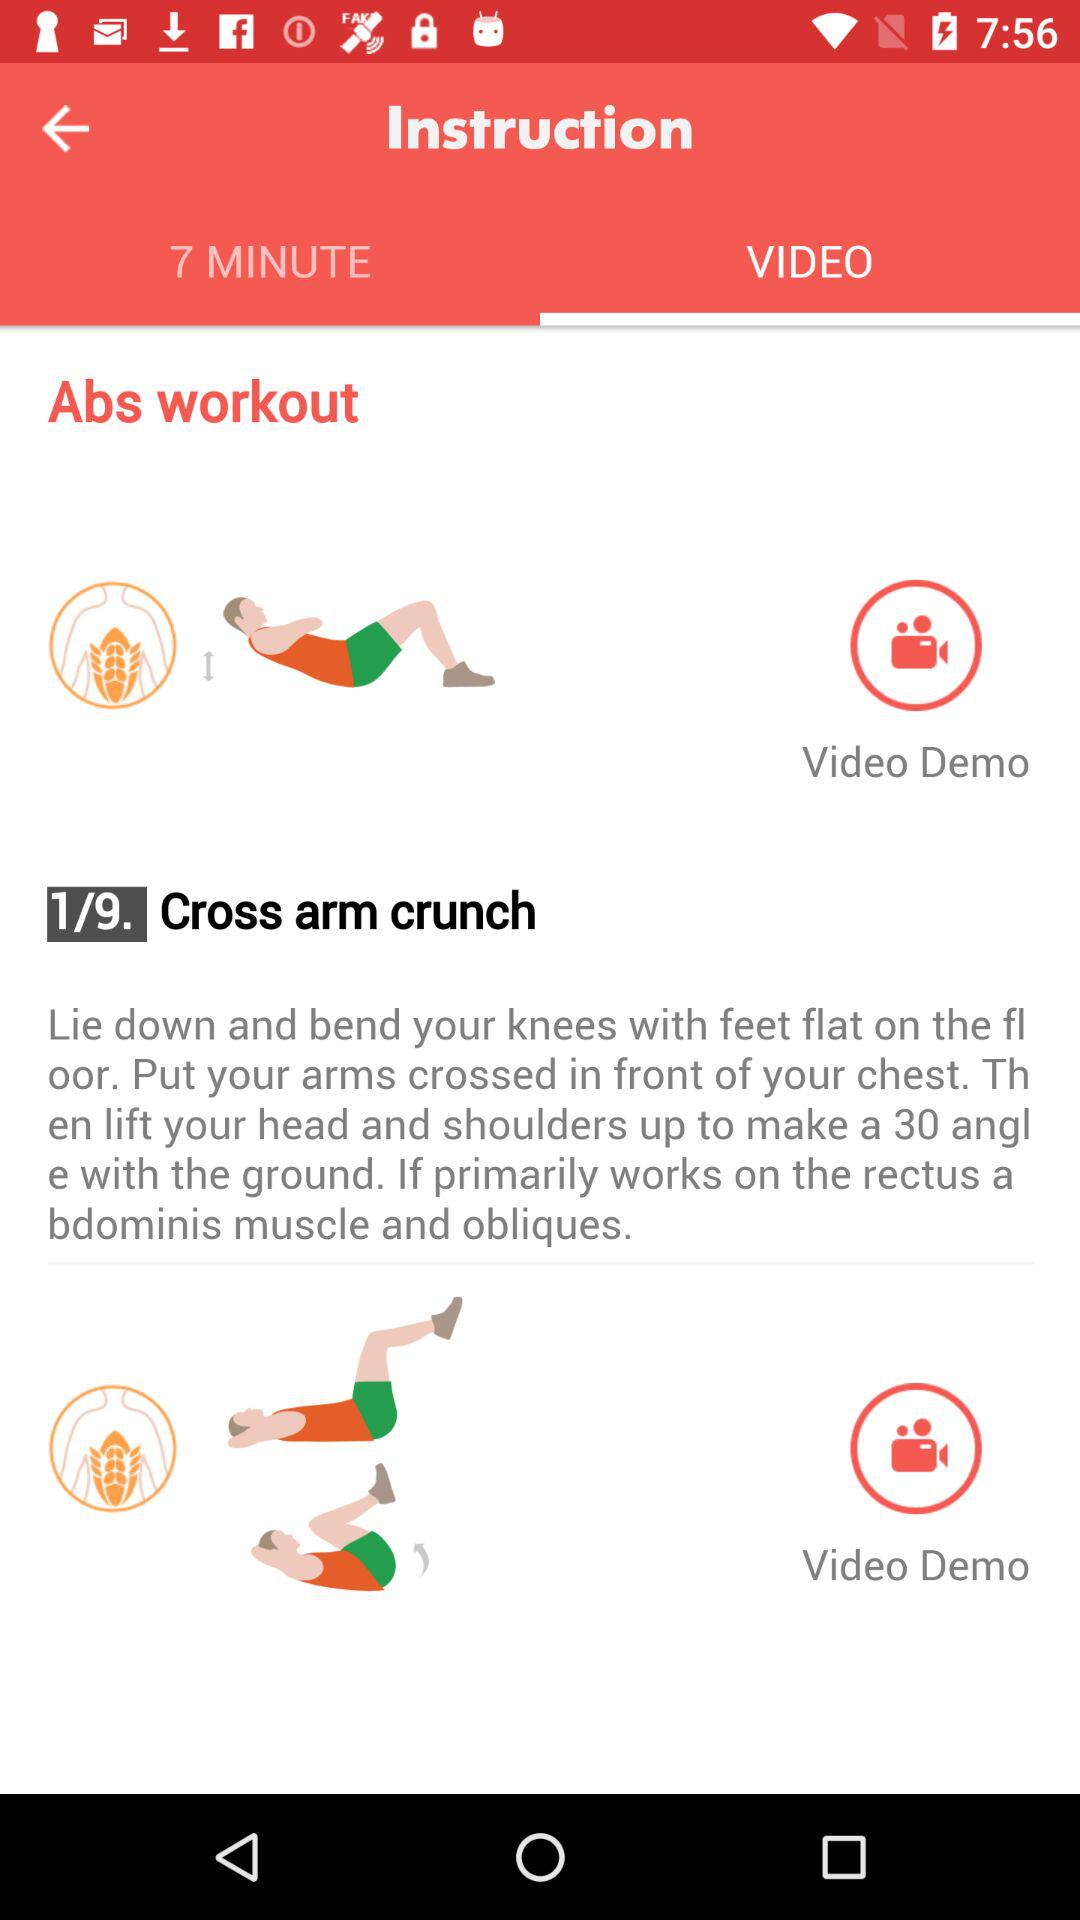What is the demo mode? The demo mode is "Video". 